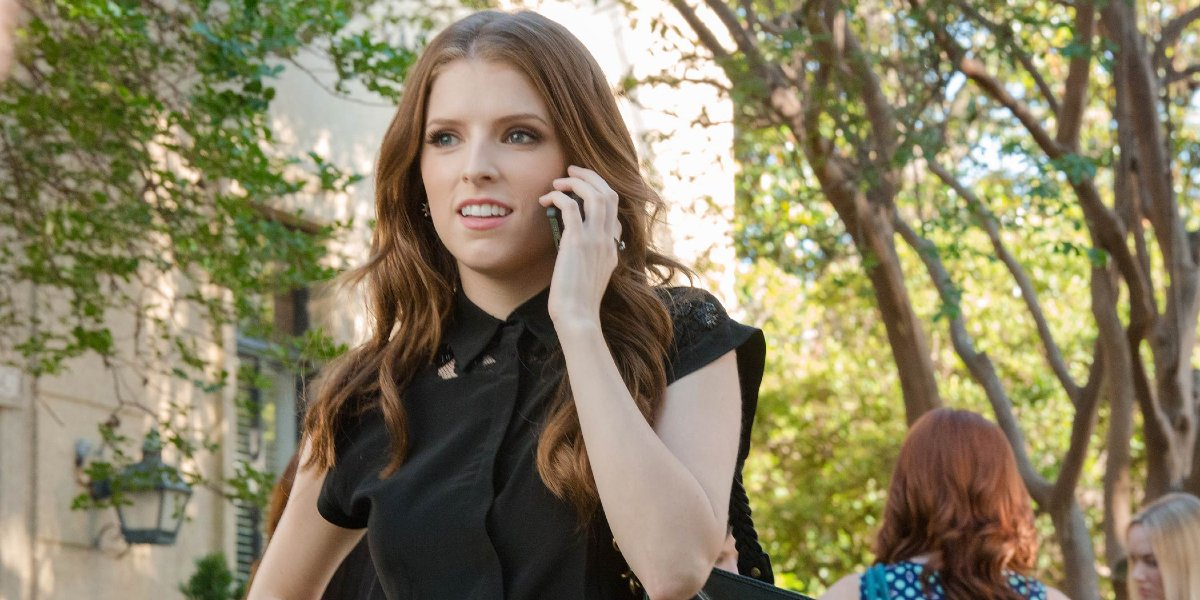What is the woman doing in this image? In this image, the woman is engaged in a phone conversation while walking down a tree-lined street. She appears to be deep in thought or perhaps even concerned about something she’s discussing over the phone. Her casual yet stylish attire and the natural setting suggest she might be taking a break or heading somewhere. She seems worried. What do you think might be the reason? There could be many reasons why she appears worried. It might be a personal issue or urgent news she received during the call. Given the candid nature of the image, it’s hard to pinpoint exactly what she’s concerned about, but the context of the phone conversation and her focused expression give a sense of urgency or importance. What could be the scenario in her conversation? Imagine she’s talking to a close friend who is going through a tough time. She's trying to offer her support and advice while balancing her own day's responsibilities. The street might be a familiar route she takes to clear her head, making call after call, offering comfort as best as she can. 